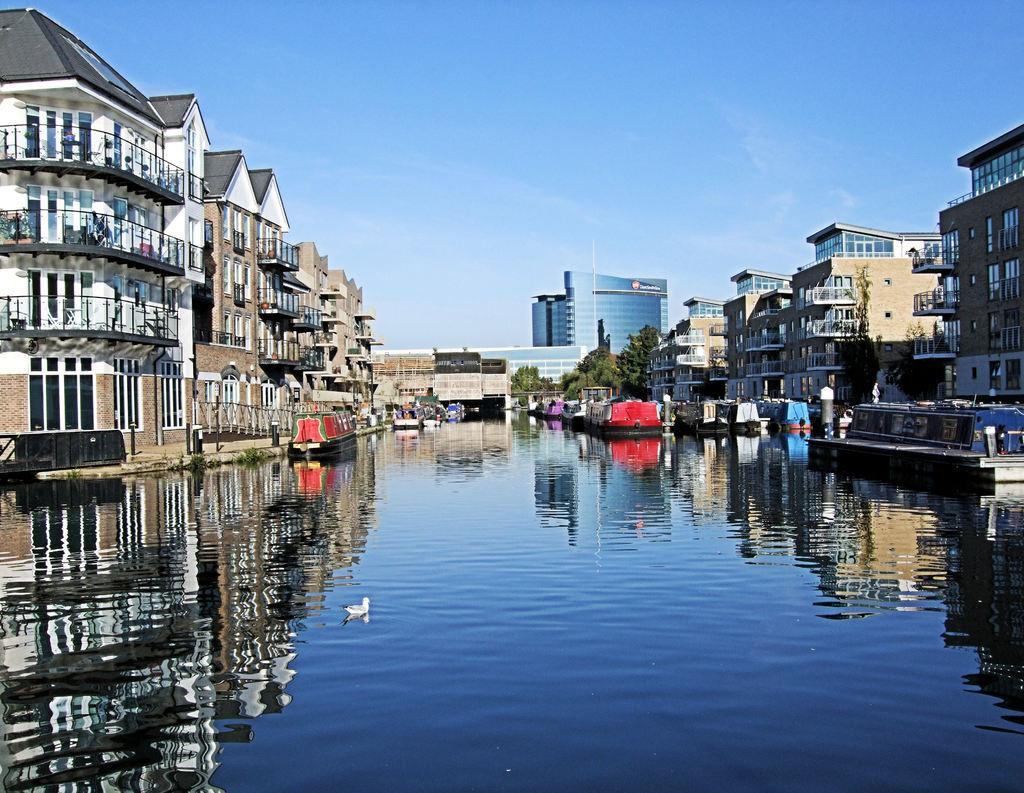Could you give a brief overview of what you see in this image? This is a picture of a city , where there is a duck in the water, boats on the water , buildings, trees, and in the background there is sky. 